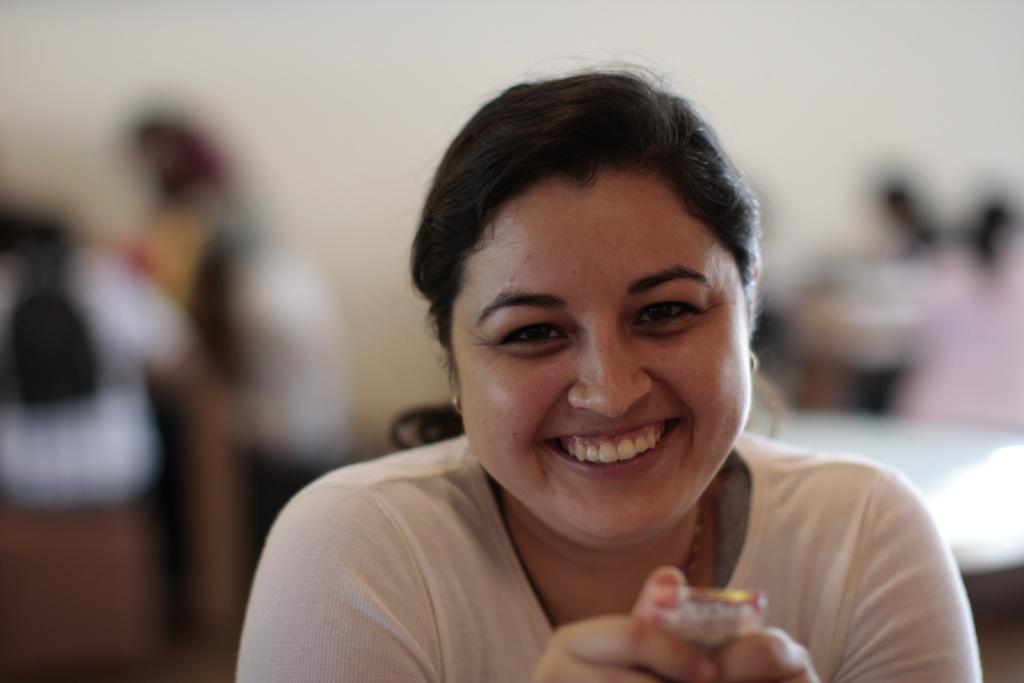Who is present in the image? There is a woman in the image. What is the woman doing in the image? The woman is laughing in the image. Can you describe the background of the image? The background of the woman is blurred in the image. What type of kettle is on the table in the image? There is no kettle or table present in the image; it only features a woman laughing with a blurred background. 